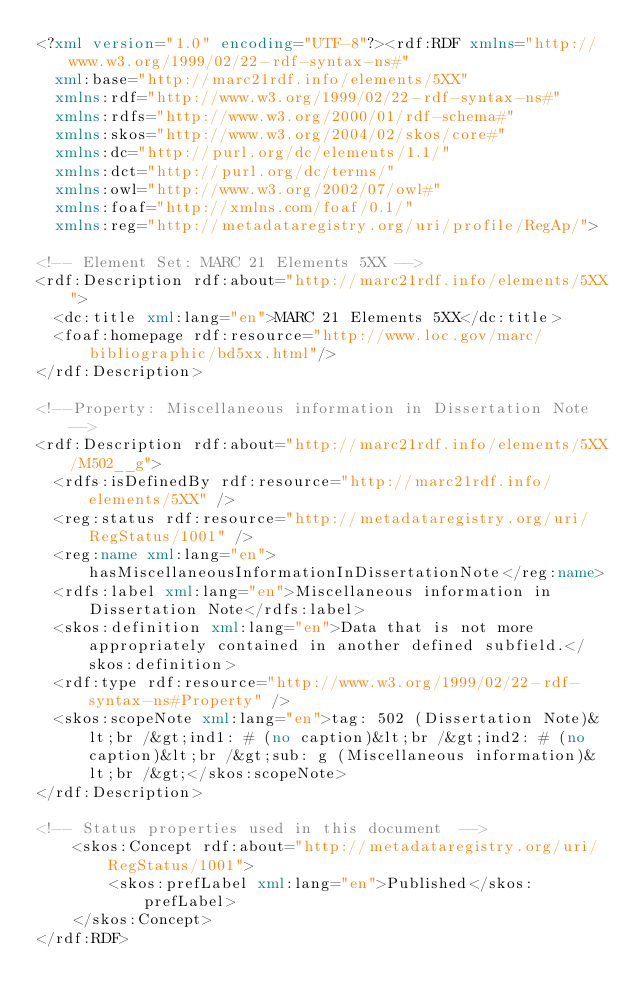Convert code to text. <code><loc_0><loc_0><loc_500><loc_500><_XML_><?xml version="1.0" encoding="UTF-8"?><rdf:RDF xmlns="http://www.w3.org/1999/02/22-rdf-syntax-ns#"
  xml:base="http://marc21rdf.info/elements/5XX"
  xmlns:rdf="http://www.w3.org/1999/02/22-rdf-syntax-ns#"
  xmlns:rdfs="http://www.w3.org/2000/01/rdf-schema#"
  xmlns:skos="http://www.w3.org/2004/02/skos/core#"
  xmlns:dc="http://purl.org/dc/elements/1.1/"
  xmlns:dct="http://purl.org/dc/terms/"
  xmlns:owl="http://www.w3.org/2002/07/owl#"
  xmlns:foaf="http://xmlns.com/foaf/0.1/"
  xmlns:reg="http://metadataregistry.org/uri/profile/RegAp/">

<!-- Element Set: MARC 21 Elements 5XX -->
<rdf:Description rdf:about="http://marc21rdf.info/elements/5XX">
  <dc:title xml:lang="en">MARC 21 Elements 5XX</dc:title>
  <foaf:homepage rdf:resource="http://www.loc.gov/marc/bibliographic/bd5xx.html"/>
</rdf:Description>

<!--Property: Miscellaneous information in Dissertation Note-->
<rdf:Description rdf:about="http://marc21rdf.info/elements/5XX/M502__g">
  <rdfs:isDefinedBy rdf:resource="http://marc21rdf.info/elements/5XX" />
  <reg:status rdf:resource="http://metadataregistry.org/uri/RegStatus/1001" />
  <reg:name xml:lang="en">hasMiscellaneousInformationInDissertationNote</reg:name>
  <rdfs:label xml:lang="en">Miscellaneous information in Dissertation Note</rdfs:label>
  <skos:definition xml:lang="en">Data that is not more appropriately contained in another defined subfield.</skos:definition>
  <rdf:type rdf:resource="http://www.w3.org/1999/02/22-rdf-syntax-ns#Property" />
  <skos:scopeNote xml:lang="en">tag: 502 (Dissertation Note)&lt;br /&gt;ind1: # (no caption)&lt;br /&gt;ind2: # (no caption)&lt;br /&gt;sub: g (Miscellaneous information)&lt;br /&gt;</skos:scopeNote>
</rdf:Description>

<!-- Status properties used in this document  -->
    <skos:Concept rdf:about="http://metadataregistry.org/uri/RegStatus/1001">
        <skos:prefLabel xml:lang="en">Published</skos:prefLabel>
    </skos:Concept>
</rdf:RDF></code> 